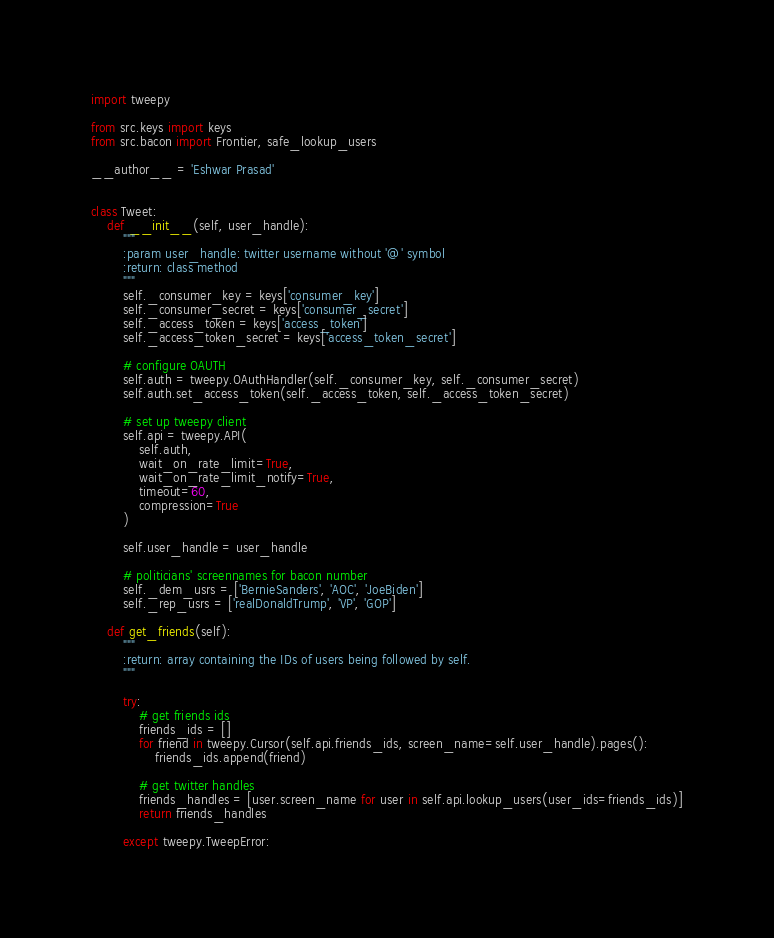<code> <loc_0><loc_0><loc_500><loc_500><_Python_>import tweepy

from src.keys import keys
from src.bacon import Frontier, safe_lookup_users

__author__ = 'Eshwar Prasad'


class Tweet:
    def __init__(self, user_handle):
        """
        :param user_handle: twitter username without '@' symbol
        :return: class method
        """
        self._consumer_key = keys['consumer_key']
        self._consumer_secret = keys['consumer_secret']
        self._access_token = keys['access_token']
        self._access_token_secret = keys['access_token_secret']

        # configure OAUTH
        self.auth = tweepy.OAuthHandler(self._consumer_key, self._consumer_secret)
        self.auth.set_access_token(self._access_token, self._access_token_secret)

        # set up tweepy client
        self.api = tweepy.API(
            self.auth,
            wait_on_rate_limit=True,
            wait_on_rate_limit_notify=True,
            timeout=60,
            compression=True
        )

        self.user_handle = user_handle

        # politicians' screennames for bacon number
        self._dem_usrs = ['BernieSanders', 'AOC', 'JoeBiden']
        self._rep_usrs = ['realDonaldTrump', 'VP', 'GOP']

    def get_friends(self):
        """
        :return: array containing the IDs of users being followed by self.
        """

        try:
            # get friends ids
            friends_ids = []
            for friend in tweepy.Cursor(self.api.friends_ids, screen_name=self.user_handle).pages():
                friends_ids.append(friend)

            # get twitter handles
            friends_handles = [user.screen_name for user in self.api.lookup_users(user_ids=friends_ids)]
            return friends_handles

        except tweepy.TweepError:</code> 